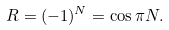Convert formula to latex. <formula><loc_0><loc_0><loc_500><loc_500>R = ( - 1 ) ^ { N } = \cos \pi N .</formula> 